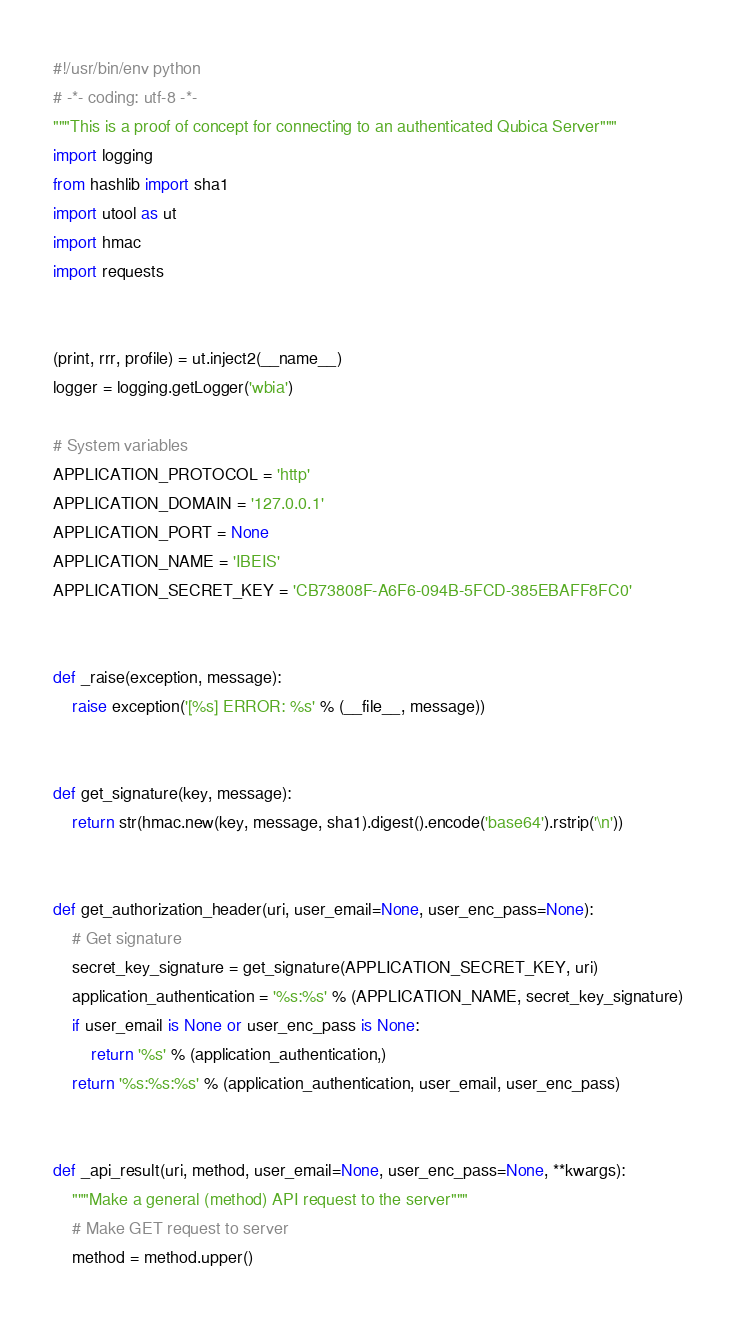Convert code to text. <code><loc_0><loc_0><loc_500><loc_500><_Python_>#!/usr/bin/env python
# -*- coding: utf-8 -*-
"""This is a proof of concept for connecting to an authenticated Qubica Server"""
import logging
from hashlib import sha1
import utool as ut
import hmac
import requests


(print, rrr, profile) = ut.inject2(__name__)
logger = logging.getLogger('wbia')

# System variables
APPLICATION_PROTOCOL = 'http'
APPLICATION_DOMAIN = '127.0.0.1'
APPLICATION_PORT = None
APPLICATION_NAME = 'IBEIS'
APPLICATION_SECRET_KEY = 'CB73808F-A6F6-094B-5FCD-385EBAFF8FC0'


def _raise(exception, message):
    raise exception('[%s] ERROR: %s' % (__file__, message))


def get_signature(key, message):
    return str(hmac.new(key, message, sha1).digest().encode('base64').rstrip('\n'))


def get_authorization_header(uri, user_email=None, user_enc_pass=None):
    # Get signature
    secret_key_signature = get_signature(APPLICATION_SECRET_KEY, uri)
    application_authentication = '%s:%s' % (APPLICATION_NAME, secret_key_signature)
    if user_email is None or user_enc_pass is None:
        return '%s' % (application_authentication,)
    return '%s:%s:%s' % (application_authentication, user_email, user_enc_pass)


def _api_result(uri, method, user_email=None, user_enc_pass=None, **kwargs):
    """Make a general (method) API request to the server"""
    # Make GET request to server
    method = method.upper()</code> 